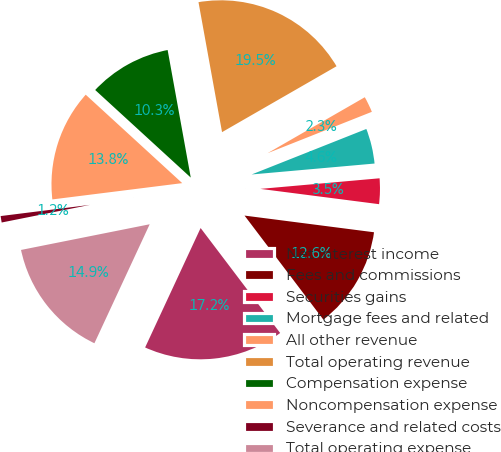Convert chart. <chart><loc_0><loc_0><loc_500><loc_500><pie_chart><fcel>Net interest income<fcel>Fees and commissions<fcel>Securities gains<fcel>Mortgage fees and related<fcel>All other revenue<fcel>Total operating revenue<fcel>Compensation expense<fcel>Noncompensation expense<fcel>Severance and related costs<fcel>Total operating expense<nl><fcel>17.24%<fcel>12.64%<fcel>3.45%<fcel>4.6%<fcel>2.3%<fcel>19.54%<fcel>10.34%<fcel>13.79%<fcel>1.15%<fcel>14.94%<nl></chart> 